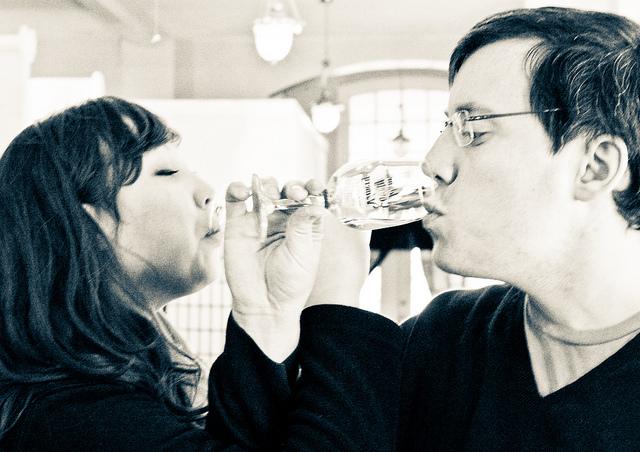How many light fixtures are in the picture?
Give a very brief answer. 3. Who wears the glasses?
Answer briefly. Man. What kind of beverage are they most likely drinking?
Short answer required. Wine. How many men are in the picture?
Keep it brief. 1. Does the lady wearing makeup?
Concise answer only. Yes. How many men are holding beverages?
Be succinct. 1. 